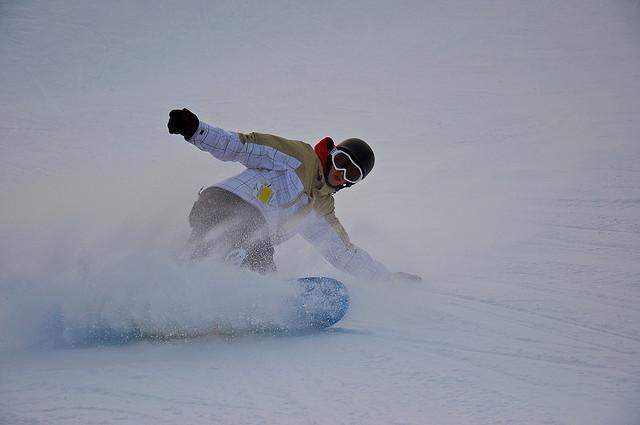Is the skier wearing sun goggles?
Quick response, please. Yes. Is the skier dress correctly for the weather?
Keep it brief. Yes. What color are the skier's gloves?
Keep it brief. Black. 